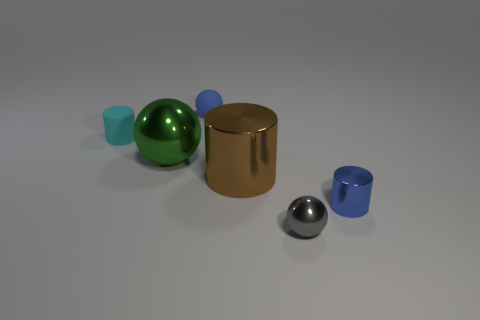Add 3 large cyan rubber blocks. How many objects exist? 9 Add 2 blue metal cylinders. How many blue metal cylinders are left? 3 Add 1 shiny objects. How many shiny objects exist? 5 Subtract 0 gray blocks. How many objects are left? 6 Subtract all brown metal things. Subtract all big metallic spheres. How many objects are left? 4 